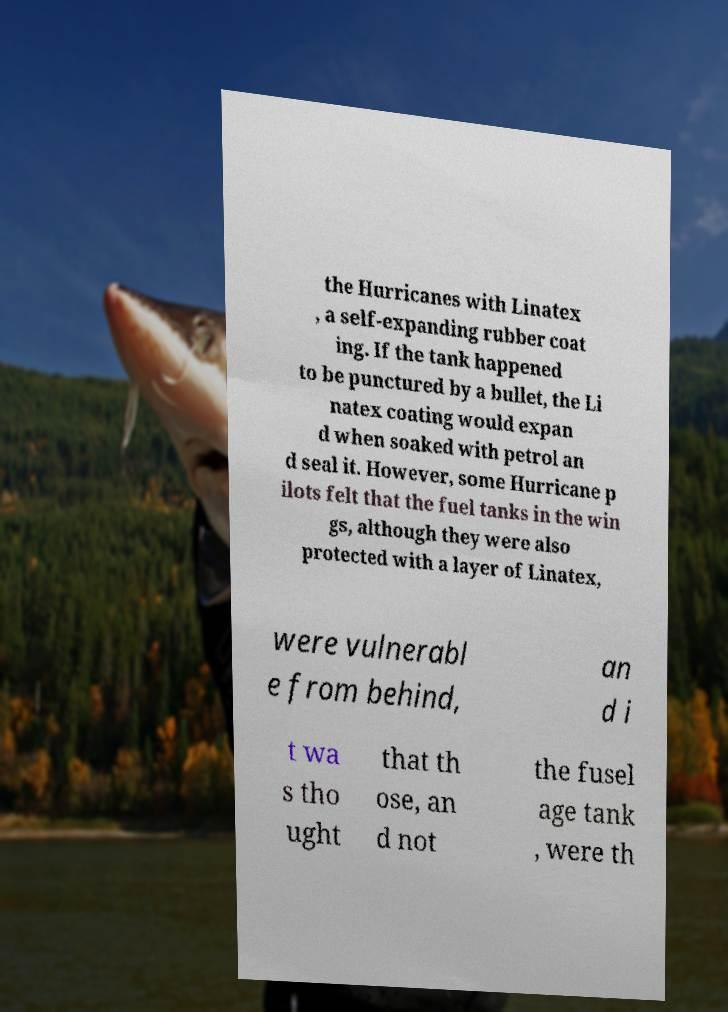Please identify and transcribe the text found in this image. the Hurricanes with Linatex , a self-expanding rubber coat ing. If the tank happened to be punctured by a bullet, the Li natex coating would expan d when soaked with petrol an d seal it. However, some Hurricane p ilots felt that the fuel tanks in the win gs, although they were also protected with a layer of Linatex, were vulnerabl e from behind, an d i t wa s tho ught that th ose, an d not the fusel age tank , were th 